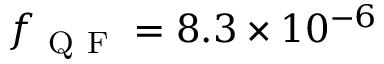<formula> <loc_0><loc_0><loc_500><loc_500>f _ { Q F } = 8 . 3 \times 1 0 ^ { - 6 }</formula> 